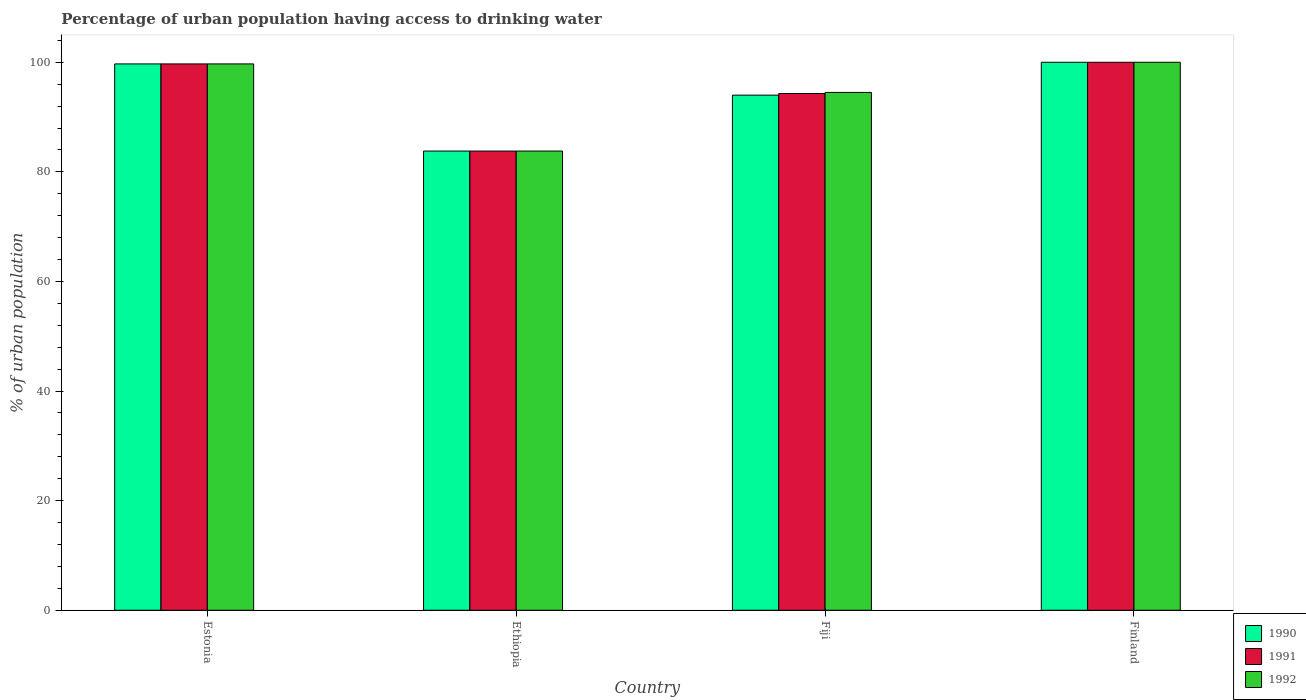How many groups of bars are there?
Provide a succinct answer. 4. Are the number of bars per tick equal to the number of legend labels?
Keep it short and to the point. Yes. How many bars are there on the 3rd tick from the left?
Give a very brief answer. 3. What is the label of the 3rd group of bars from the left?
Your response must be concise. Fiji. In how many cases, is the number of bars for a given country not equal to the number of legend labels?
Keep it short and to the point. 0. What is the percentage of urban population having access to drinking water in 1992 in Estonia?
Offer a terse response. 99.7. Across all countries, what is the minimum percentage of urban population having access to drinking water in 1990?
Give a very brief answer. 83.8. In which country was the percentage of urban population having access to drinking water in 1992 minimum?
Your answer should be compact. Ethiopia. What is the total percentage of urban population having access to drinking water in 1991 in the graph?
Provide a short and direct response. 377.8. What is the difference between the percentage of urban population having access to drinking water in 1991 in Fiji and that in Finland?
Ensure brevity in your answer.  -5.7. What is the difference between the percentage of urban population having access to drinking water in 1990 in Fiji and the percentage of urban population having access to drinking water in 1991 in Finland?
Ensure brevity in your answer.  -6. What is the average percentage of urban population having access to drinking water in 1992 per country?
Provide a succinct answer. 94.5. What is the difference between the percentage of urban population having access to drinking water of/in 1990 and percentage of urban population having access to drinking water of/in 1991 in Fiji?
Make the answer very short. -0.3. What is the ratio of the percentage of urban population having access to drinking water in 1991 in Estonia to that in Finland?
Your answer should be compact. 1. What is the difference between the highest and the second highest percentage of urban population having access to drinking water in 1991?
Your answer should be compact. -0.3. What is the difference between the highest and the lowest percentage of urban population having access to drinking water in 1992?
Provide a succinct answer. 16.2. In how many countries, is the percentage of urban population having access to drinking water in 1990 greater than the average percentage of urban population having access to drinking water in 1990 taken over all countries?
Provide a succinct answer. 2. Is the sum of the percentage of urban population having access to drinking water in 1991 in Ethiopia and Finland greater than the maximum percentage of urban population having access to drinking water in 1992 across all countries?
Your answer should be compact. Yes. What does the 2nd bar from the left in Estonia represents?
Your answer should be compact. 1991. Is it the case that in every country, the sum of the percentage of urban population having access to drinking water in 1991 and percentage of urban population having access to drinking water in 1992 is greater than the percentage of urban population having access to drinking water in 1990?
Provide a succinct answer. Yes. How many bars are there?
Offer a terse response. 12. How many countries are there in the graph?
Your answer should be compact. 4. Does the graph contain any zero values?
Offer a very short reply. No. Where does the legend appear in the graph?
Provide a succinct answer. Bottom right. What is the title of the graph?
Make the answer very short. Percentage of urban population having access to drinking water. What is the label or title of the Y-axis?
Your response must be concise. % of urban population. What is the % of urban population of 1990 in Estonia?
Make the answer very short. 99.7. What is the % of urban population of 1991 in Estonia?
Make the answer very short. 99.7. What is the % of urban population of 1992 in Estonia?
Provide a short and direct response. 99.7. What is the % of urban population in 1990 in Ethiopia?
Your answer should be very brief. 83.8. What is the % of urban population of 1991 in Ethiopia?
Keep it short and to the point. 83.8. What is the % of urban population of 1992 in Ethiopia?
Your response must be concise. 83.8. What is the % of urban population in 1990 in Fiji?
Make the answer very short. 94. What is the % of urban population in 1991 in Fiji?
Your response must be concise. 94.3. What is the % of urban population of 1992 in Fiji?
Offer a terse response. 94.5. What is the % of urban population of 1990 in Finland?
Your response must be concise. 100. What is the % of urban population in 1992 in Finland?
Give a very brief answer. 100. Across all countries, what is the minimum % of urban population of 1990?
Offer a very short reply. 83.8. Across all countries, what is the minimum % of urban population of 1991?
Offer a terse response. 83.8. Across all countries, what is the minimum % of urban population in 1992?
Keep it short and to the point. 83.8. What is the total % of urban population in 1990 in the graph?
Keep it short and to the point. 377.5. What is the total % of urban population in 1991 in the graph?
Offer a very short reply. 377.8. What is the total % of urban population in 1992 in the graph?
Keep it short and to the point. 378. What is the difference between the % of urban population in 1991 in Estonia and that in Ethiopia?
Give a very brief answer. 15.9. What is the difference between the % of urban population of 1992 in Estonia and that in Ethiopia?
Provide a succinct answer. 15.9. What is the difference between the % of urban population of 1992 in Estonia and that in Fiji?
Provide a succinct answer. 5.2. What is the difference between the % of urban population in 1990 in Estonia and that in Finland?
Provide a short and direct response. -0.3. What is the difference between the % of urban population in 1990 in Ethiopia and that in Fiji?
Offer a very short reply. -10.2. What is the difference between the % of urban population in 1990 in Ethiopia and that in Finland?
Offer a terse response. -16.2. What is the difference between the % of urban population of 1991 in Ethiopia and that in Finland?
Make the answer very short. -16.2. What is the difference between the % of urban population of 1992 in Ethiopia and that in Finland?
Your response must be concise. -16.2. What is the difference between the % of urban population of 1990 in Fiji and that in Finland?
Provide a succinct answer. -6. What is the difference between the % of urban population of 1990 in Estonia and the % of urban population of 1992 in Ethiopia?
Ensure brevity in your answer.  15.9. What is the difference between the % of urban population in 1991 in Estonia and the % of urban population in 1992 in Ethiopia?
Give a very brief answer. 15.9. What is the difference between the % of urban population of 1991 in Estonia and the % of urban population of 1992 in Finland?
Give a very brief answer. -0.3. What is the difference between the % of urban population of 1990 in Ethiopia and the % of urban population of 1992 in Fiji?
Your response must be concise. -10.7. What is the difference between the % of urban population in 1990 in Ethiopia and the % of urban population in 1991 in Finland?
Provide a succinct answer. -16.2. What is the difference between the % of urban population of 1990 in Ethiopia and the % of urban population of 1992 in Finland?
Give a very brief answer. -16.2. What is the difference between the % of urban population in 1991 in Ethiopia and the % of urban population in 1992 in Finland?
Keep it short and to the point. -16.2. What is the average % of urban population in 1990 per country?
Your answer should be compact. 94.38. What is the average % of urban population of 1991 per country?
Your response must be concise. 94.45. What is the average % of urban population of 1992 per country?
Make the answer very short. 94.5. What is the difference between the % of urban population in 1990 and % of urban population in 1991 in Estonia?
Your response must be concise. 0. What is the difference between the % of urban population in 1991 and % of urban population in 1992 in Estonia?
Provide a succinct answer. 0. What is the difference between the % of urban population in 1990 and % of urban population in 1991 in Ethiopia?
Give a very brief answer. 0. What is the difference between the % of urban population of 1991 and % of urban population of 1992 in Fiji?
Offer a very short reply. -0.2. What is the difference between the % of urban population of 1990 and % of urban population of 1992 in Finland?
Make the answer very short. 0. What is the ratio of the % of urban population in 1990 in Estonia to that in Ethiopia?
Keep it short and to the point. 1.19. What is the ratio of the % of urban population in 1991 in Estonia to that in Ethiopia?
Your response must be concise. 1.19. What is the ratio of the % of urban population in 1992 in Estonia to that in Ethiopia?
Offer a terse response. 1.19. What is the ratio of the % of urban population of 1990 in Estonia to that in Fiji?
Provide a short and direct response. 1.06. What is the ratio of the % of urban population of 1991 in Estonia to that in Fiji?
Provide a succinct answer. 1.06. What is the ratio of the % of urban population in 1992 in Estonia to that in Fiji?
Keep it short and to the point. 1.05. What is the ratio of the % of urban population in 1990 in Estonia to that in Finland?
Offer a terse response. 1. What is the ratio of the % of urban population in 1991 in Estonia to that in Finland?
Give a very brief answer. 1. What is the ratio of the % of urban population of 1990 in Ethiopia to that in Fiji?
Make the answer very short. 0.89. What is the ratio of the % of urban population of 1991 in Ethiopia to that in Fiji?
Your response must be concise. 0.89. What is the ratio of the % of urban population of 1992 in Ethiopia to that in Fiji?
Your answer should be very brief. 0.89. What is the ratio of the % of urban population of 1990 in Ethiopia to that in Finland?
Offer a very short reply. 0.84. What is the ratio of the % of urban population in 1991 in Ethiopia to that in Finland?
Your response must be concise. 0.84. What is the ratio of the % of urban population in 1992 in Ethiopia to that in Finland?
Your answer should be very brief. 0.84. What is the ratio of the % of urban population of 1991 in Fiji to that in Finland?
Give a very brief answer. 0.94. What is the ratio of the % of urban population of 1992 in Fiji to that in Finland?
Offer a very short reply. 0.94. What is the difference between the highest and the second highest % of urban population in 1991?
Your response must be concise. 0.3. What is the difference between the highest and the second highest % of urban population of 1992?
Your response must be concise. 0.3. What is the difference between the highest and the lowest % of urban population of 1990?
Provide a short and direct response. 16.2. What is the difference between the highest and the lowest % of urban population of 1991?
Your answer should be very brief. 16.2. 